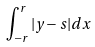Convert formula to latex. <formula><loc_0><loc_0><loc_500><loc_500>\int _ { - r } ^ { r } | y - s | d x</formula> 